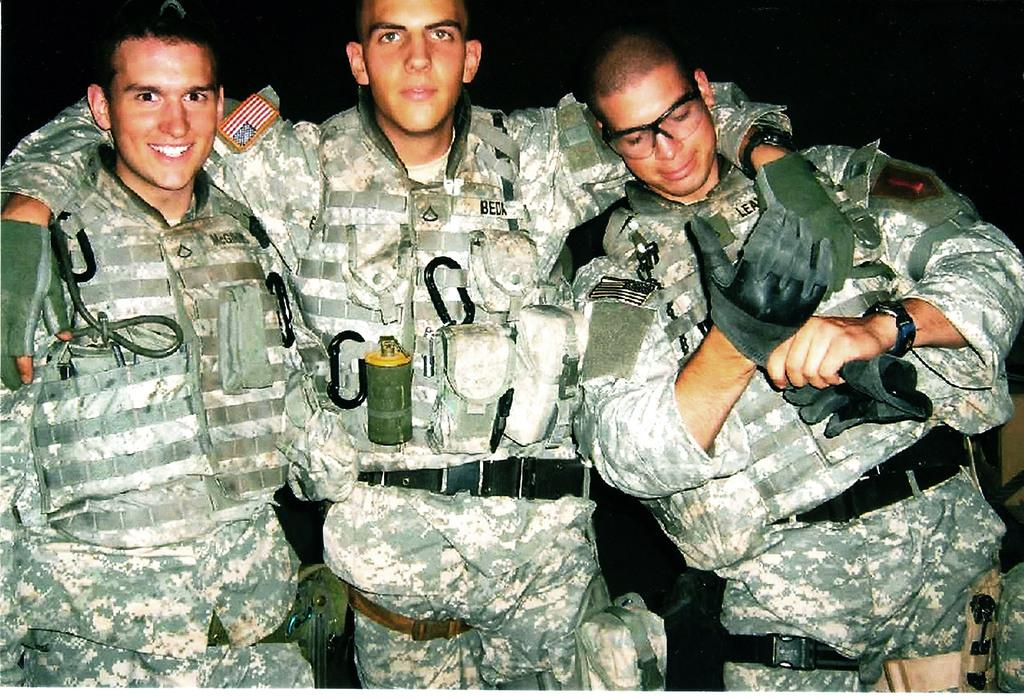How many people are in the image? There are three persons in the image. What can be observed about the background of the image? The background of the image is dark. What type of shop can be seen in the image? There is no shop present in the image; it only features three persons. What color is the silver object in the image? There is no silver object present in the image. 